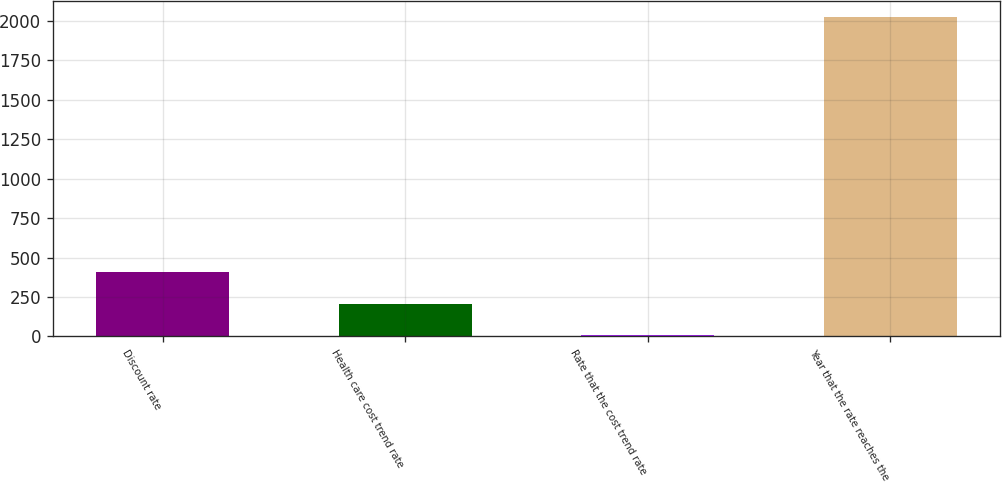Convert chart. <chart><loc_0><loc_0><loc_500><loc_500><bar_chart><fcel>Discount rate<fcel>Health care cost trend rate<fcel>Rate that the cost trend rate<fcel>Year that the rate reaches the<nl><fcel>409.7<fcel>207.91<fcel>6.12<fcel>2024<nl></chart> 